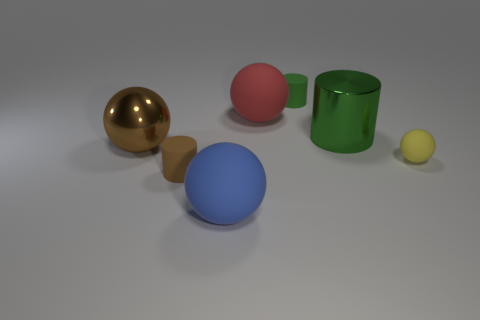How many big things are either objects or blue shiny balls?
Offer a very short reply. 4. Is there any other thing that has the same color as the large cylinder?
Make the answer very short. Yes. Do the matte object on the left side of the blue rubber object and the green rubber thing have the same size?
Your response must be concise. Yes. What is the color of the small cylinder that is to the right of the small cylinder to the left of the green cylinder that is behind the red sphere?
Provide a succinct answer. Green. The big cylinder is what color?
Provide a short and direct response. Green. Do the large metallic cylinder and the big metal sphere have the same color?
Provide a succinct answer. No. Is the large thing that is in front of the tiny brown rubber cylinder made of the same material as the small cylinder that is behind the brown rubber object?
Your response must be concise. Yes. What material is the brown object that is the same shape as the yellow thing?
Offer a very short reply. Metal. Do the yellow ball and the big brown thing have the same material?
Offer a very short reply. No. What color is the metallic object that is on the left side of the green object to the right of the green matte object?
Your answer should be very brief. Brown. 